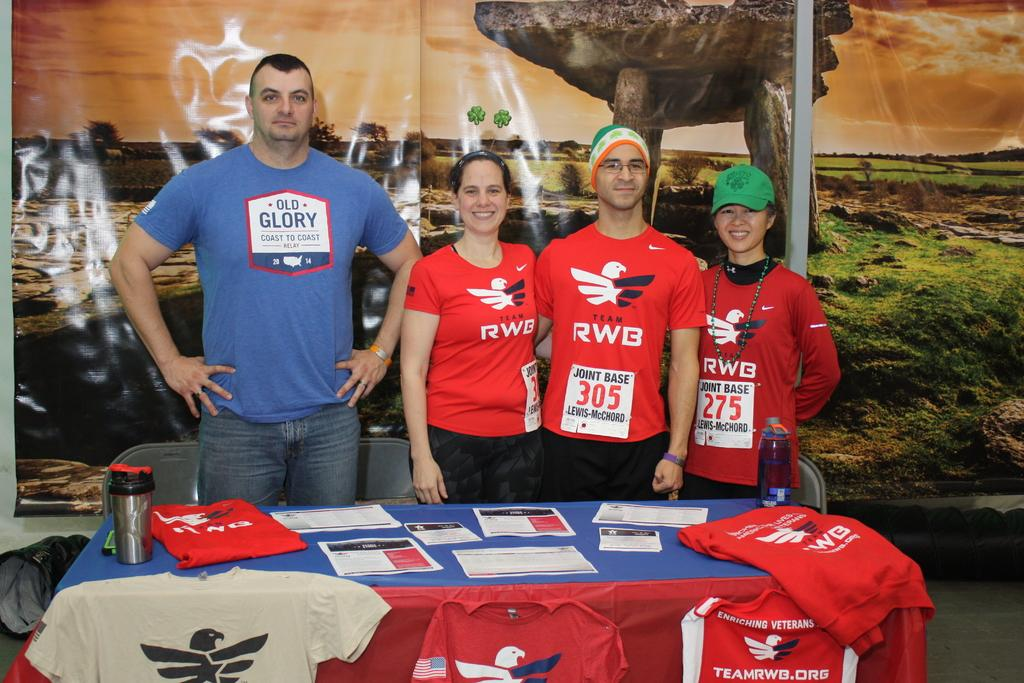<image>
Give a short and clear explanation of the subsequent image. The team wearing red is currently called Team RWB 